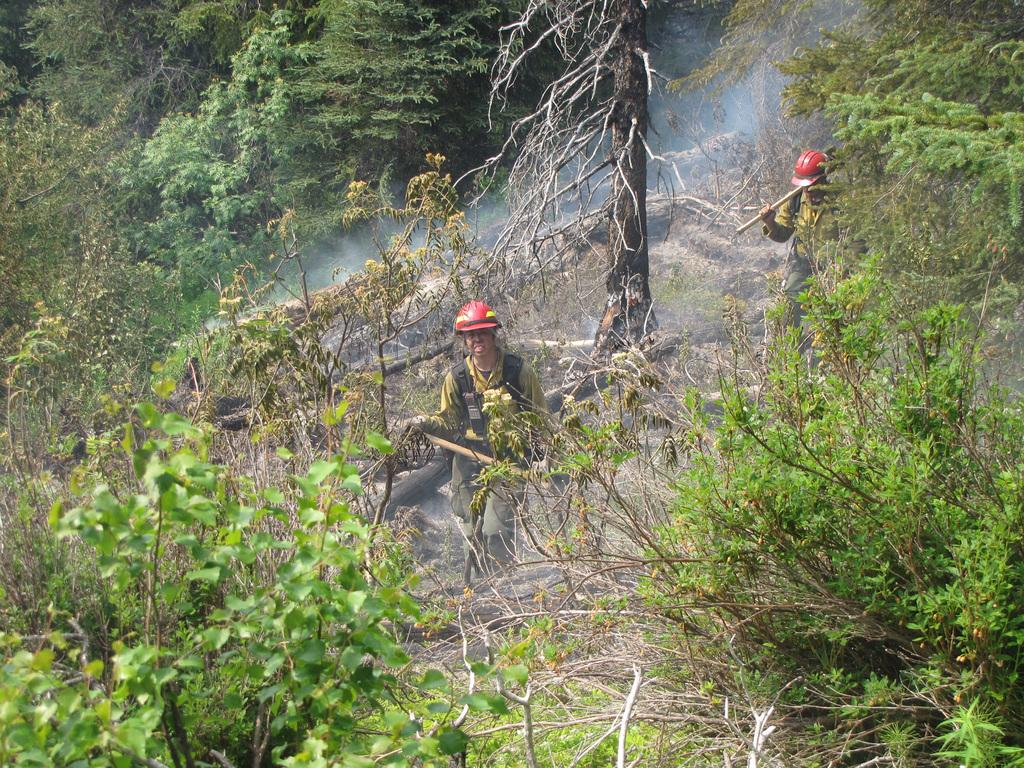How many people are in the image? There are two persons in the image. What are the persons doing in the image? The persons are walking. What can be seen in the background of the image? There are trees in the background of the image. What is visible in the foreground of the image? There are plants in the foreground of the image. What type of basketball court can be seen in the image? There is no basketball court present in the image. What kind of box is being carried by the persons in the image? There is no box being carried by the persons in the image. 